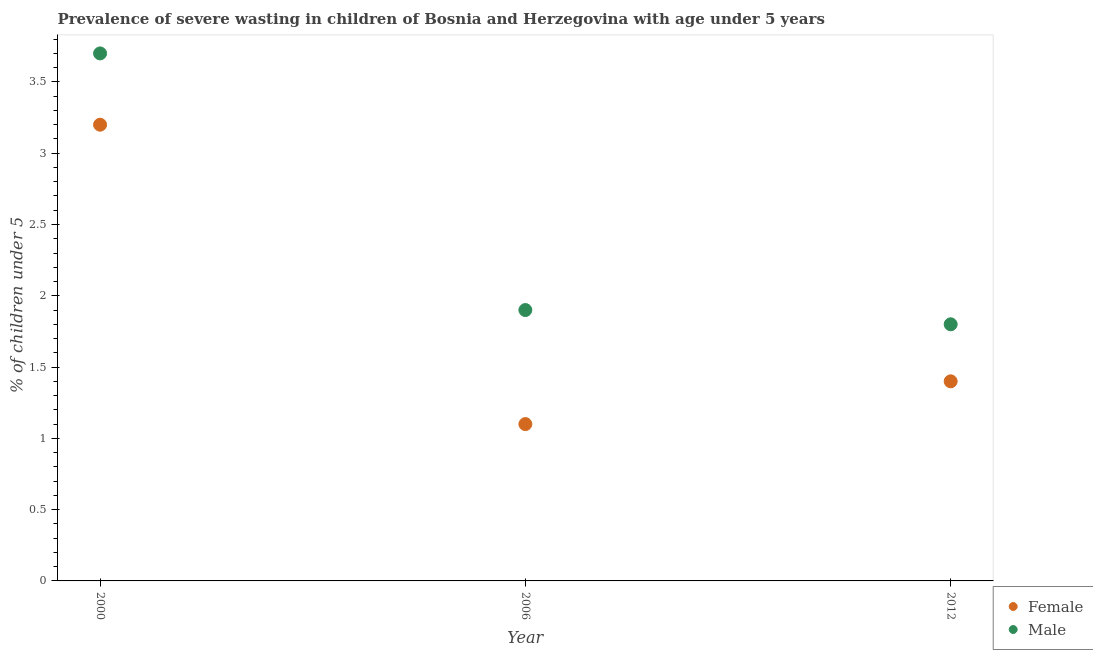Is the number of dotlines equal to the number of legend labels?
Provide a short and direct response. Yes. What is the percentage of undernourished female children in 2012?
Your answer should be compact. 1.4. Across all years, what is the maximum percentage of undernourished male children?
Keep it short and to the point. 3.7. Across all years, what is the minimum percentage of undernourished female children?
Make the answer very short. 1.1. In which year was the percentage of undernourished female children maximum?
Make the answer very short. 2000. In which year was the percentage of undernourished female children minimum?
Keep it short and to the point. 2006. What is the total percentage of undernourished male children in the graph?
Offer a terse response. 7.4. What is the difference between the percentage of undernourished female children in 2000 and that in 2012?
Provide a short and direct response. 1.8. What is the difference between the percentage of undernourished male children in 2006 and the percentage of undernourished female children in 2012?
Your answer should be compact. 0.5. What is the average percentage of undernourished female children per year?
Ensure brevity in your answer.  1.9. In the year 2012, what is the difference between the percentage of undernourished female children and percentage of undernourished male children?
Keep it short and to the point. -0.4. What is the ratio of the percentage of undernourished male children in 2006 to that in 2012?
Offer a very short reply. 1.06. Is the percentage of undernourished female children in 2006 less than that in 2012?
Your answer should be very brief. Yes. Is the difference between the percentage of undernourished male children in 2000 and 2006 greater than the difference between the percentage of undernourished female children in 2000 and 2006?
Provide a succinct answer. No. What is the difference between the highest and the second highest percentage of undernourished male children?
Keep it short and to the point. 1.8. What is the difference between the highest and the lowest percentage of undernourished female children?
Make the answer very short. 2.1. Is the sum of the percentage of undernourished male children in 2000 and 2006 greater than the maximum percentage of undernourished female children across all years?
Give a very brief answer. Yes. Is the percentage of undernourished male children strictly less than the percentage of undernourished female children over the years?
Keep it short and to the point. No. How many dotlines are there?
Offer a terse response. 2. What is the difference between two consecutive major ticks on the Y-axis?
Offer a very short reply. 0.5. Does the graph contain any zero values?
Provide a succinct answer. No. Does the graph contain grids?
Ensure brevity in your answer.  No. How many legend labels are there?
Make the answer very short. 2. How are the legend labels stacked?
Ensure brevity in your answer.  Vertical. What is the title of the graph?
Offer a terse response. Prevalence of severe wasting in children of Bosnia and Herzegovina with age under 5 years. What is the label or title of the X-axis?
Provide a short and direct response. Year. What is the label or title of the Y-axis?
Ensure brevity in your answer.   % of children under 5. What is the  % of children under 5 in Female in 2000?
Offer a terse response. 3.2. What is the  % of children under 5 of Male in 2000?
Give a very brief answer. 3.7. What is the  % of children under 5 of Female in 2006?
Provide a succinct answer. 1.1. What is the  % of children under 5 in Male in 2006?
Your answer should be very brief. 1.9. What is the  % of children under 5 of Female in 2012?
Your response must be concise. 1.4. What is the  % of children under 5 of Male in 2012?
Your answer should be compact. 1.8. Across all years, what is the maximum  % of children under 5 of Female?
Your answer should be compact. 3.2. Across all years, what is the maximum  % of children under 5 in Male?
Your response must be concise. 3.7. Across all years, what is the minimum  % of children under 5 of Female?
Your answer should be very brief. 1.1. Across all years, what is the minimum  % of children under 5 in Male?
Ensure brevity in your answer.  1.8. What is the difference between the  % of children under 5 in Male in 2000 and that in 2006?
Give a very brief answer. 1.8. What is the difference between the  % of children under 5 in Male in 2000 and that in 2012?
Give a very brief answer. 1.9. What is the difference between the  % of children under 5 in Male in 2006 and that in 2012?
Make the answer very short. 0.1. What is the average  % of children under 5 of Male per year?
Ensure brevity in your answer.  2.47. What is the ratio of the  % of children under 5 of Female in 2000 to that in 2006?
Offer a terse response. 2.91. What is the ratio of the  % of children under 5 in Male in 2000 to that in 2006?
Offer a very short reply. 1.95. What is the ratio of the  % of children under 5 in Female in 2000 to that in 2012?
Provide a short and direct response. 2.29. What is the ratio of the  % of children under 5 of Male in 2000 to that in 2012?
Offer a terse response. 2.06. What is the ratio of the  % of children under 5 of Female in 2006 to that in 2012?
Give a very brief answer. 0.79. What is the ratio of the  % of children under 5 of Male in 2006 to that in 2012?
Provide a succinct answer. 1.06. What is the difference between the highest and the second highest  % of children under 5 of Female?
Provide a succinct answer. 1.8. What is the difference between the highest and the lowest  % of children under 5 in Female?
Provide a succinct answer. 2.1. What is the difference between the highest and the lowest  % of children under 5 in Male?
Keep it short and to the point. 1.9. 